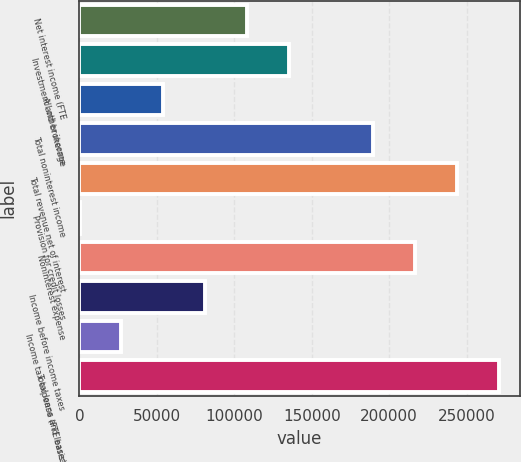Convert chart. <chart><loc_0><loc_0><loc_500><loc_500><bar_chart><fcel>Net interest income (FTE<fcel>Investment and brokerage<fcel>All other income<fcel>Total noninterest income<fcel>Total revenue net of interest<fcel>Provision for credit losses<fcel>Noninterest expense<fcel>Income before income taxes<fcel>Income tax expense (FTE basis)<fcel>Total loans and leases<nl><fcel>108349<fcel>135422<fcel>54202.6<fcel>189569<fcel>243716<fcel>56<fcel>216642<fcel>81275.9<fcel>27129.3<fcel>270789<nl></chart> 